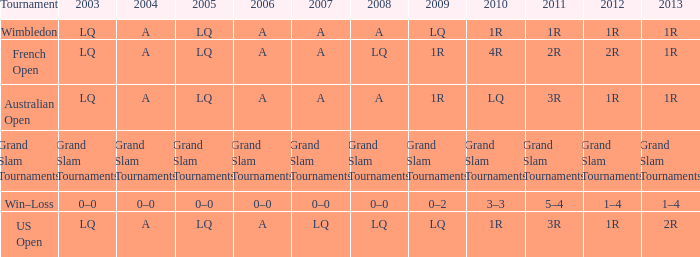I'm looking to parse the entire table for insights. Could you assist me with that? {'header': ['Tournament', '2003', '2004', '2005', '2006', '2007', '2008', '2009', '2010', '2011', '2012', '2013'], 'rows': [['Wimbledon', 'LQ', 'A', 'LQ', 'A', 'A', 'A', 'LQ', '1R', '1R', '1R', '1R'], ['French Open', 'LQ', 'A', 'LQ', 'A', 'A', 'LQ', '1R', '4R', '2R', '2R', '1R'], ['Australian Open', 'LQ', 'A', 'LQ', 'A', 'A', 'A', '1R', 'LQ', '3R', '1R', '1R'], ['Grand Slam Tournaments', 'Grand Slam Tournaments', 'Grand Slam Tournaments', 'Grand Slam Tournaments', 'Grand Slam Tournaments', 'Grand Slam Tournaments', 'Grand Slam Tournaments', 'Grand Slam Tournaments', 'Grand Slam Tournaments', 'Grand Slam Tournaments', 'Grand Slam Tournaments', 'Grand Slam Tournaments'], ['Win–Loss', '0–0', '0–0', '0–0', '0–0', '0–0', '0–0', '0–2', '3–3', '5–4', '1–4', '1–4'], ['US Open', 'LQ', 'A', 'LQ', 'A', 'LQ', 'LQ', 'LQ', '1R', '3R', '1R', '2R']]} Which year has a 2003 of lq? 1R, 1R, LQ, LQ. 